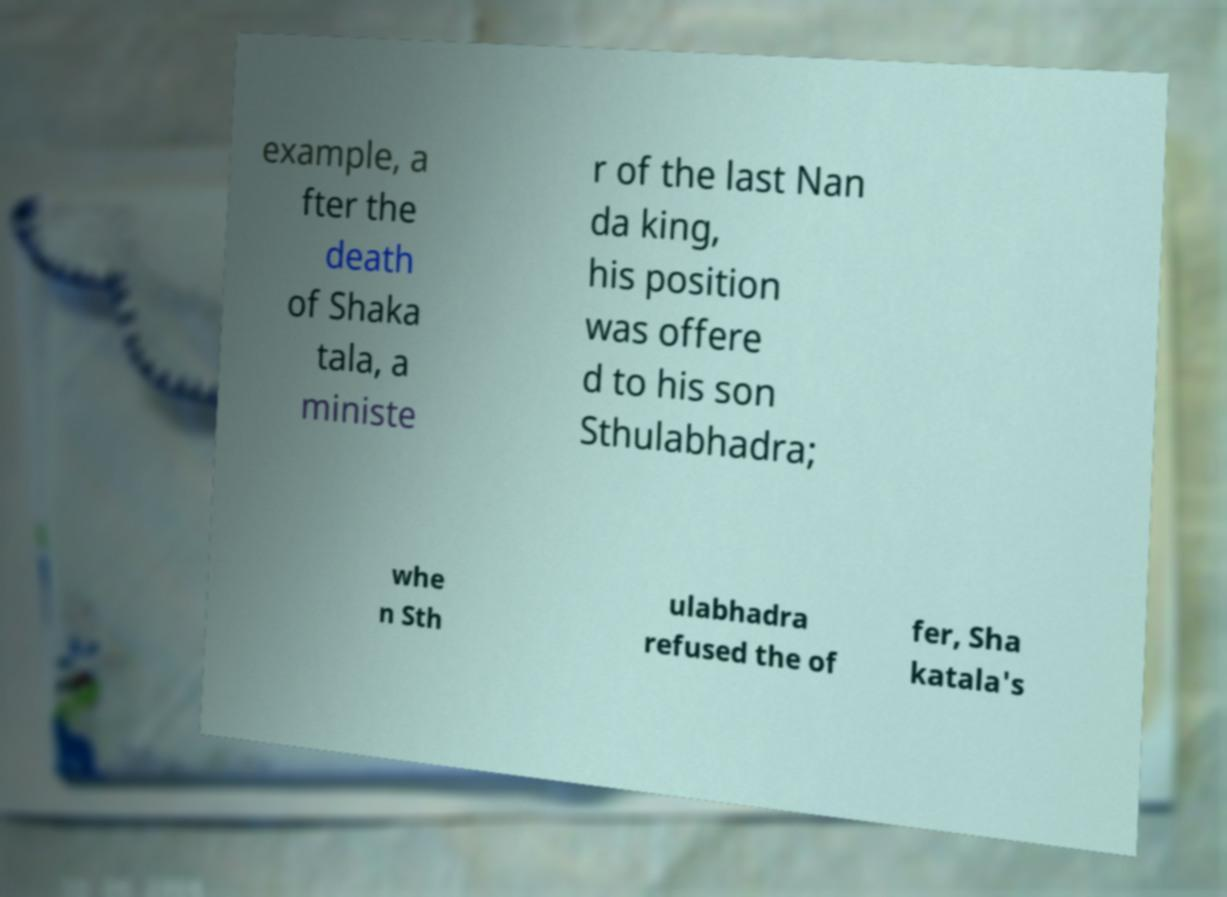There's text embedded in this image that I need extracted. Can you transcribe it verbatim? example, a fter the death of Shaka tala, a ministe r of the last Nan da king, his position was offere d to his son Sthulabhadra; whe n Sth ulabhadra refused the of fer, Sha katala's 